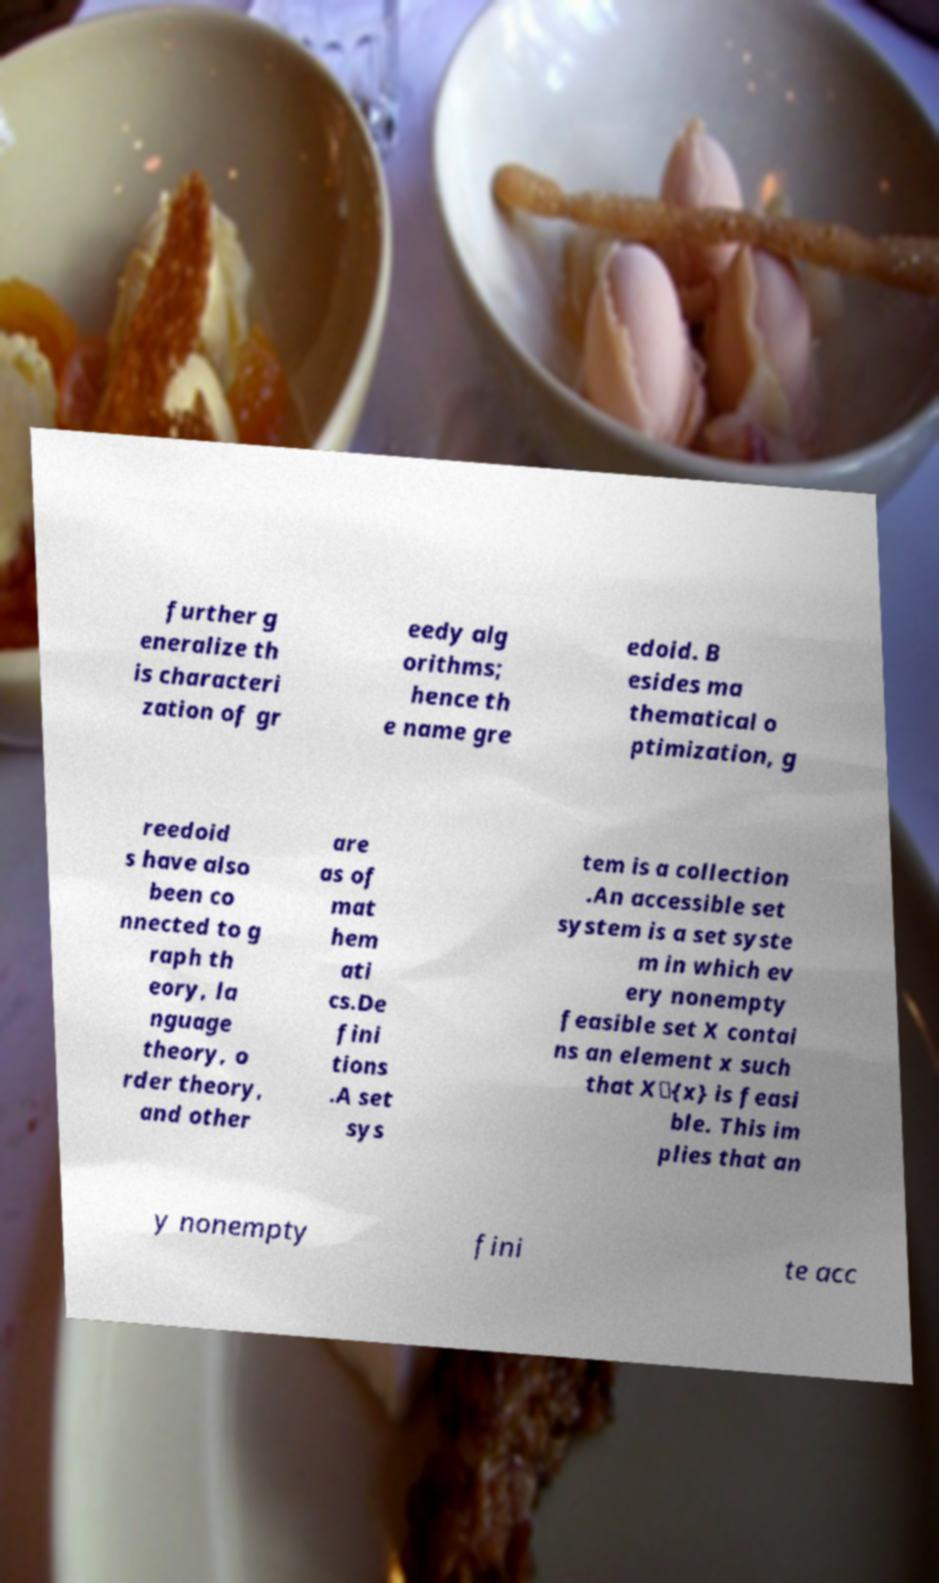What messages or text are displayed in this image? I need them in a readable, typed format. further g eneralize th is characteri zation of gr eedy alg orithms; hence th e name gre edoid. B esides ma thematical o ptimization, g reedoid s have also been co nnected to g raph th eory, la nguage theory, o rder theory, and other are as of mat hem ati cs.De fini tions .A set sys tem is a collection .An accessible set system is a set syste m in which ev ery nonempty feasible set X contai ns an element x such that X\{x} is feasi ble. This im plies that an y nonempty fini te acc 